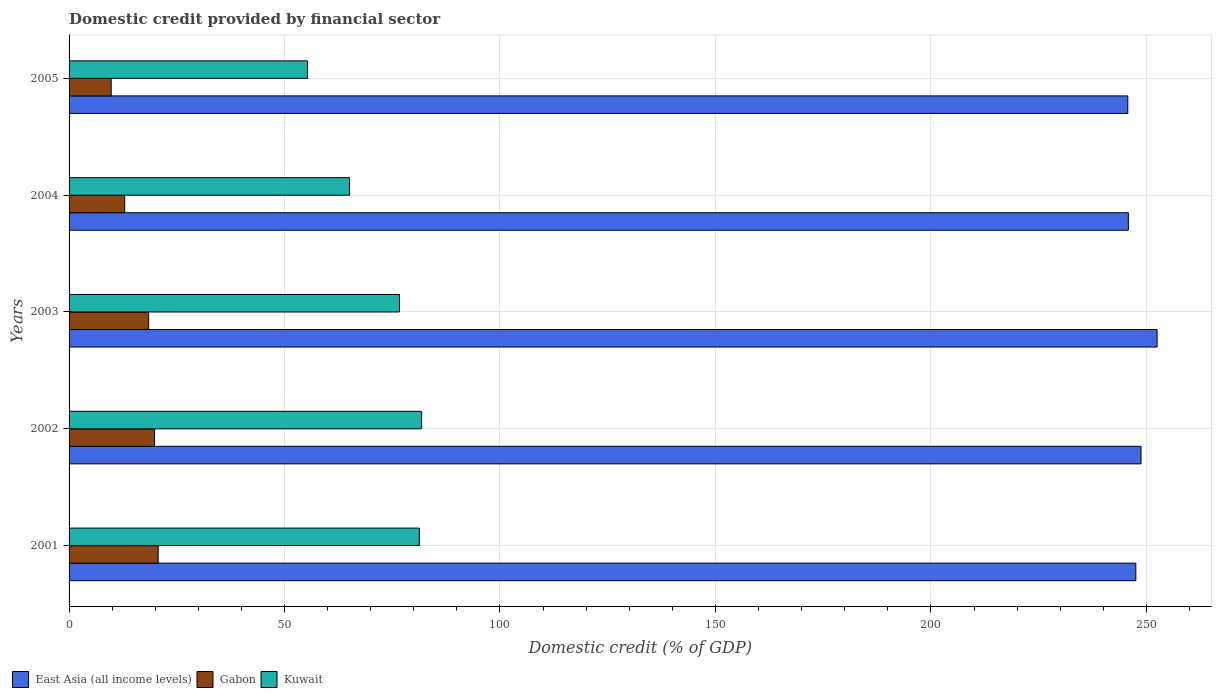How many groups of bars are there?
Provide a succinct answer. 5. Are the number of bars per tick equal to the number of legend labels?
Provide a succinct answer. Yes. Are the number of bars on each tick of the Y-axis equal?
Give a very brief answer. Yes. How many bars are there on the 4th tick from the top?
Offer a terse response. 3. What is the label of the 5th group of bars from the top?
Make the answer very short. 2001. In how many cases, is the number of bars for a given year not equal to the number of legend labels?
Provide a short and direct response. 0. What is the domestic credit in East Asia (all income levels) in 2004?
Provide a short and direct response. 245.82. Across all years, what is the maximum domestic credit in East Asia (all income levels)?
Provide a short and direct response. 252.49. Across all years, what is the minimum domestic credit in Gabon?
Your answer should be compact. 9.77. In which year was the domestic credit in Gabon maximum?
Give a very brief answer. 2001. What is the total domestic credit in East Asia (all income levels) in the graph?
Your answer should be very brief. 1240.33. What is the difference between the domestic credit in East Asia (all income levels) in 2001 and that in 2003?
Give a very brief answer. -4.93. What is the difference between the domestic credit in Kuwait in 2005 and the domestic credit in East Asia (all income levels) in 2002?
Give a very brief answer. -193.44. What is the average domestic credit in Gabon per year?
Make the answer very short. 16.33. In the year 2005, what is the difference between the domestic credit in Gabon and domestic credit in Kuwait?
Ensure brevity in your answer.  -45.55. In how many years, is the domestic credit in Gabon greater than 130 %?
Make the answer very short. 0. What is the ratio of the domestic credit in Gabon in 2002 to that in 2005?
Your answer should be compact. 2.03. Is the domestic credit in East Asia (all income levels) in 2003 less than that in 2004?
Keep it short and to the point. No. What is the difference between the highest and the second highest domestic credit in Gabon?
Provide a short and direct response. 0.86. What is the difference between the highest and the lowest domestic credit in Kuwait?
Provide a short and direct response. 26.49. In how many years, is the domestic credit in Kuwait greater than the average domestic credit in Kuwait taken over all years?
Your response must be concise. 3. What does the 1st bar from the top in 2003 represents?
Offer a terse response. Kuwait. What does the 2nd bar from the bottom in 2004 represents?
Provide a short and direct response. Gabon. Are all the bars in the graph horizontal?
Your answer should be very brief. Yes. How many years are there in the graph?
Your response must be concise. 5. What is the difference between two consecutive major ticks on the X-axis?
Make the answer very short. 50. Are the values on the major ticks of X-axis written in scientific E-notation?
Your answer should be very brief. No. Does the graph contain grids?
Ensure brevity in your answer.  Yes. Where does the legend appear in the graph?
Keep it short and to the point. Bottom left. How are the legend labels stacked?
Your response must be concise. Horizontal. What is the title of the graph?
Your answer should be compact. Domestic credit provided by financial sector. Does "Belarus" appear as one of the legend labels in the graph?
Keep it short and to the point. No. What is the label or title of the X-axis?
Your response must be concise. Domestic credit (% of GDP). What is the Domestic credit (% of GDP) of East Asia (all income levels) in 2001?
Keep it short and to the point. 247.56. What is the Domestic credit (% of GDP) in Gabon in 2001?
Your answer should be very brief. 20.68. What is the Domestic credit (% of GDP) of Kuwait in 2001?
Provide a short and direct response. 81.27. What is the Domestic credit (% of GDP) of East Asia (all income levels) in 2002?
Your response must be concise. 248.76. What is the Domestic credit (% of GDP) of Gabon in 2002?
Keep it short and to the point. 19.82. What is the Domestic credit (% of GDP) of Kuwait in 2002?
Provide a short and direct response. 81.81. What is the Domestic credit (% of GDP) of East Asia (all income levels) in 2003?
Give a very brief answer. 252.49. What is the Domestic credit (% of GDP) of Gabon in 2003?
Make the answer very short. 18.47. What is the Domestic credit (% of GDP) in Kuwait in 2003?
Ensure brevity in your answer.  76.68. What is the Domestic credit (% of GDP) of East Asia (all income levels) in 2004?
Give a very brief answer. 245.82. What is the Domestic credit (% of GDP) of Gabon in 2004?
Provide a succinct answer. 12.91. What is the Domestic credit (% of GDP) in Kuwait in 2004?
Make the answer very short. 65.09. What is the Domestic credit (% of GDP) of East Asia (all income levels) in 2005?
Make the answer very short. 245.69. What is the Domestic credit (% of GDP) in Gabon in 2005?
Provide a succinct answer. 9.77. What is the Domestic credit (% of GDP) in Kuwait in 2005?
Your answer should be compact. 55.32. Across all years, what is the maximum Domestic credit (% of GDP) in East Asia (all income levels)?
Your answer should be compact. 252.49. Across all years, what is the maximum Domestic credit (% of GDP) of Gabon?
Offer a very short reply. 20.68. Across all years, what is the maximum Domestic credit (% of GDP) of Kuwait?
Ensure brevity in your answer.  81.81. Across all years, what is the minimum Domestic credit (% of GDP) in East Asia (all income levels)?
Give a very brief answer. 245.69. Across all years, what is the minimum Domestic credit (% of GDP) of Gabon?
Your answer should be very brief. 9.77. Across all years, what is the minimum Domestic credit (% of GDP) of Kuwait?
Your answer should be compact. 55.32. What is the total Domestic credit (% of GDP) of East Asia (all income levels) in the graph?
Keep it short and to the point. 1240.33. What is the total Domestic credit (% of GDP) in Gabon in the graph?
Your answer should be compact. 81.65. What is the total Domestic credit (% of GDP) of Kuwait in the graph?
Your answer should be compact. 360.18. What is the difference between the Domestic credit (% of GDP) in East Asia (all income levels) in 2001 and that in 2002?
Offer a terse response. -1.21. What is the difference between the Domestic credit (% of GDP) of Gabon in 2001 and that in 2002?
Your response must be concise. 0.86. What is the difference between the Domestic credit (% of GDP) in Kuwait in 2001 and that in 2002?
Provide a short and direct response. -0.54. What is the difference between the Domestic credit (% of GDP) of East Asia (all income levels) in 2001 and that in 2003?
Your response must be concise. -4.93. What is the difference between the Domestic credit (% of GDP) in Gabon in 2001 and that in 2003?
Your response must be concise. 2.22. What is the difference between the Domestic credit (% of GDP) in Kuwait in 2001 and that in 2003?
Make the answer very short. 4.6. What is the difference between the Domestic credit (% of GDP) of East Asia (all income levels) in 2001 and that in 2004?
Make the answer very short. 1.74. What is the difference between the Domestic credit (% of GDP) of Gabon in 2001 and that in 2004?
Your answer should be compact. 7.77. What is the difference between the Domestic credit (% of GDP) in Kuwait in 2001 and that in 2004?
Make the answer very short. 16.18. What is the difference between the Domestic credit (% of GDP) in East Asia (all income levels) in 2001 and that in 2005?
Offer a very short reply. 1.87. What is the difference between the Domestic credit (% of GDP) in Gabon in 2001 and that in 2005?
Ensure brevity in your answer.  10.91. What is the difference between the Domestic credit (% of GDP) in Kuwait in 2001 and that in 2005?
Provide a short and direct response. 25.95. What is the difference between the Domestic credit (% of GDP) in East Asia (all income levels) in 2002 and that in 2003?
Provide a short and direct response. -3.72. What is the difference between the Domestic credit (% of GDP) of Gabon in 2002 and that in 2003?
Your response must be concise. 1.36. What is the difference between the Domestic credit (% of GDP) of Kuwait in 2002 and that in 2003?
Your answer should be very brief. 5.13. What is the difference between the Domestic credit (% of GDP) of East Asia (all income levels) in 2002 and that in 2004?
Keep it short and to the point. 2.94. What is the difference between the Domestic credit (% of GDP) of Gabon in 2002 and that in 2004?
Provide a succinct answer. 6.92. What is the difference between the Domestic credit (% of GDP) in Kuwait in 2002 and that in 2004?
Your answer should be compact. 16.72. What is the difference between the Domestic credit (% of GDP) in East Asia (all income levels) in 2002 and that in 2005?
Ensure brevity in your answer.  3.07. What is the difference between the Domestic credit (% of GDP) in Gabon in 2002 and that in 2005?
Offer a very short reply. 10.05. What is the difference between the Domestic credit (% of GDP) of Kuwait in 2002 and that in 2005?
Ensure brevity in your answer.  26.49. What is the difference between the Domestic credit (% of GDP) in East Asia (all income levels) in 2003 and that in 2004?
Make the answer very short. 6.67. What is the difference between the Domestic credit (% of GDP) in Gabon in 2003 and that in 2004?
Offer a very short reply. 5.56. What is the difference between the Domestic credit (% of GDP) of Kuwait in 2003 and that in 2004?
Keep it short and to the point. 11.59. What is the difference between the Domestic credit (% of GDP) in East Asia (all income levels) in 2003 and that in 2005?
Provide a short and direct response. 6.8. What is the difference between the Domestic credit (% of GDP) of Gabon in 2003 and that in 2005?
Ensure brevity in your answer.  8.69. What is the difference between the Domestic credit (% of GDP) in Kuwait in 2003 and that in 2005?
Give a very brief answer. 21.36. What is the difference between the Domestic credit (% of GDP) in East Asia (all income levels) in 2004 and that in 2005?
Provide a succinct answer. 0.13. What is the difference between the Domestic credit (% of GDP) of Gabon in 2004 and that in 2005?
Provide a succinct answer. 3.14. What is the difference between the Domestic credit (% of GDP) in Kuwait in 2004 and that in 2005?
Offer a terse response. 9.77. What is the difference between the Domestic credit (% of GDP) of East Asia (all income levels) in 2001 and the Domestic credit (% of GDP) of Gabon in 2002?
Your answer should be compact. 227.74. What is the difference between the Domestic credit (% of GDP) of East Asia (all income levels) in 2001 and the Domestic credit (% of GDP) of Kuwait in 2002?
Your answer should be very brief. 165.75. What is the difference between the Domestic credit (% of GDP) of Gabon in 2001 and the Domestic credit (% of GDP) of Kuwait in 2002?
Give a very brief answer. -61.13. What is the difference between the Domestic credit (% of GDP) in East Asia (all income levels) in 2001 and the Domestic credit (% of GDP) in Gabon in 2003?
Ensure brevity in your answer.  229.09. What is the difference between the Domestic credit (% of GDP) of East Asia (all income levels) in 2001 and the Domestic credit (% of GDP) of Kuwait in 2003?
Provide a succinct answer. 170.88. What is the difference between the Domestic credit (% of GDP) in Gabon in 2001 and the Domestic credit (% of GDP) in Kuwait in 2003?
Your answer should be very brief. -56. What is the difference between the Domestic credit (% of GDP) in East Asia (all income levels) in 2001 and the Domestic credit (% of GDP) in Gabon in 2004?
Provide a succinct answer. 234.65. What is the difference between the Domestic credit (% of GDP) of East Asia (all income levels) in 2001 and the Domestic credit (% of GDP) of Kuwait in 2004?
Offer a terse response. 182.47. What is the difference between the Domestic credit (% of GDP) in Gabon in 2001 and the Domestic credit (% of GDP) in Kuwait in 2004?
Give a very brief answer. -44.41. What is the difference between the Domestic credit (% of GDP) of East Asia (all income levels) in 2001 and the Domestic credit (% of GDP) of Gabon in 2005?
Offer a terse response. 237.79. What is the difference between the Domestic credit (% of GDP) in East Asia (all income levels) in 2001 and the Domestic credit (% of GDP) in Kuwait in 2005?
Give a very brief answer. 192.24. What is the difference between the Domestic credit (% of GDP) of Gabon in 2001 and the Domestic credit (% of GDP) of Kuwait in 2005?
Ensure brevity in your answer.  -34.64. What is the difference between the Domestic credit (% of GDP) of East Asia (all income levels) in 2002 and the Domestic credit (% of GDP) of Gabon in 2003?
Ensure brevity in your answer.  230.3. What is the difference between the Domestic credit (% of GDP) of East Asia (all income levels) in 2002 and the Domestic credit (% of GDP) of Kuwait in 2003?
Offer a very short reply. 172.09. What is the difference between the Domestic credit (% of GDP) of Gabon in 2002 and the Domestic credit (% of GDP) of Kuwait in 2003?
Make the answer very short. -56.85. What is the difference between the Domestic credit (% of GDP) in East Asia (all income levels) in 2002 and the Domestic credit (% of GDP) in Gabon in 2004?
Ensure brevity in your answer.  235.86. What is the difference between the Domestic credit (% of GDP) of East Asia (all income levels) in 2002 and the Domestic credit (% of GDP) of Kuwait in 2004?
Your answer should be compact. 183.67. What is the difference between the Domestic credit (% of GDP) of Gabon in 2002 and the Domestic credit (% of GDP) of Kuwait in 2004?
Keep it short and to the point. -45.27. What is the difference between the Domestic credit (% of GDP) in East Asia (all income levels) in 2002 and the Domestic credit (% of GDP) in Gabon in 2005?
Offer a terse response. 238.99. What is the difference between the Domestic credit (% of GDP) in East Asia (all income levels) in 2002 and the Domestic credit (% of GDP) in Kuwait in 2005?
Your answer should be very brief. 193.44. What is the difference between the Domestic credit (% of GDP) in Gabon in 2002 and the Domestic credit (% of GDP) in Kuwait in 2005?
Make the answer very short. -35.5. What is the difference between the Domestic credit (% of GDP) of East Asia (all income levels) in 2003 and the Domestic credit (% of GDP) of Gabon in 2004?
Make the answer very short. 239.58. What is the difference between the Domestic credit (% of GDP) of East Asia (all income levels) in 2003 and the Domestic credit (% of GDP) of Kuwait in 2004?
Give a very brief answer. 187.4. What is the difference between the Domestic credit (% of GDP) in Gabon in 2003 and the Domestic credit (% of GDP) in Kuwait in 2004?
Provide a succinct answer. -46.63. What is the difference between the Domestic credit (% of GDP) of East Asia (all income levels) in 2003 and the Domestic credit (% of GDP) of Gabon in 2005?
Make the answer very short. 242.72. What is the difference between the Domestic credit (% of GDP) in East Asia (all income levels) in 2003 and the Domestic credit (% of GDP) in Kuwait in 2005?
Your answer should be very brief. 197.17. What is the difference between the Domestic credit (% of GDP) in Gabon in 2003 and the Domestic credit (% of GDP) in Kuwait in 2005?
Give a very brief answer. -36.86. What is the difference between the Domestic credit (% of GDP) of East Asia (all income levels) in 2004 and the Domestic credit (% of GDP) of Gabon in 2005?
Provide a short and direct response. 236.05. What is the difference between the Domestic credit (% of GDP) of East Asia (all income levels) in 2004 and the Domestic credit (% of GDP) of Kuwait in 2005?
Your response must be concise. 190.5. What is the difference between the Domestic credit (% of GDP) of Gabon in 2004 and the Domestic credit (% of GDP) of Kuwait in 2005?
Your response must be concise. -42.41. What is the average Domestic credit (% of GDP) in East Asia (all income levels) per year?
Ensure brevity in your answer.  248.07. What is the average Domestic credit (% of GDP) of Gabon per year?
Ensure brevity in your answer.  16.33. What is the average Domestic credit (% of GDP) in Kuwait per year?
Your answer should be compact. 72.03. In the year 2001, what is the difference between the Domestic credit (% of GDP) of East Asia (all income levels) and Domestic credit (% of GDP) of Gabon?
Offer a terse response. 226.88. In the year 2001, what is the difference between the Domestic credit (% of GDP) in East Asia (all income levels) and Domestic credit (% of GDP) in Kuwait?
Your answer should be very brief. 166.28. In the year 2001, what is the difference between the Domestic credit (% of GDP) of Gabon and Domestic credit (% of GDP) of Kuwait?
Keep it short and to the point. -60.59. In the year 2002, what is the difference between the Domestic credit (% of GDP) in East Asia (all income levels) and Domestic credit (% of GDP) in Gabon?
Keep it short and to the point. 228.94. In the year 2002, what is the difference between the Domestic credit (% of GDP) of East Asia (all income levels) and Domestic credit (% of GDP) of Kuwait?
Provide a succinct answer. 166.95. In the year 2002, what is the difference between the Domestic credit (% of GDP) of Gabon and Domestic credit (% of GDP) of Kuwait?
Provide a short and direct response. -61.99. In the year 2003, what is the difference between the Domestic credit (% of GDP) in East Asia (all income levels) and Domestic credit (% of GDP) in Gabon?
Your answer should be very brief. 234.02. In the year 2003, what is the difference between the Domestic credit (% of GDP) of East Asia (all income levels) and Domestic credit (% of GDP) of Kuwait?
Offer a very short reply. 175.81. In the year 2003, what is the difference between the Domestic credit (% of GDP) of Gabon and Domestic credit (% of GDP) of Kuwait?
Give a very brief answer. -58.21. In the year 2004, what is the difference between the Domestic credit (% of GDP) of East Asia (all income levels) and Domestic credit (% of GDP) of Gabon?
Give a very brief answer. 232.92. In the year 2004, what is the difference between the Domestic credit (% of GDP) of East Asia (all income levels) and Domestic credit (% of GDP) of Kuwait?
Your answer should be very brief. 180.73. In the year 2004, what is the difference between the Domestic credit (% of GDP) of Gabon and Domestic credit (% of GDP) of Kuwait?
Make the answer very short. -52.18. In the year 2005, what is the difference between the Domestic credit (% of GDP) of East Asia (all income levels) and Domestic credit (% of GDP) of Gabon?
Offer a terse response. 235.92. In the year 2005, what is the difference between the Domestic credit (% of GDP) in East Asia (all income levels) and Domestic credit (% of GDP) in Kuwait?
Offer a very short reply. 190.37. In the year 2005, what is the difference between the Domestic credit (% of GDP) of Gabon and Domestic credit (% of GDP) of Kuwait?
Make the answer very short. -45.55. What is the ratio of the Domestic credit (% of GDP) in East Asia (all income levels) in 2001 to that in 2002?
Offer a very short reply. 1. What is the ratio of the Domestic credit (% of GDP) of Gabon in 2001 to that in 2002?
Offer a very short reply. 1.04. What is the ratio of the Domestic credit (% of GDP) of Kuwait in 2001 to that in 2002?
Offer a very short reply. 0.99. What is the ratio of the Domestic credit (% of GDP) of East Asia (all income levels) in 2001 to that in 2003?
Provide a succinct answer. 0.98. What is the ratio of the Domestic credit (% of GDP) of Gabon in 2001 to that in 2003?
Offer a very short reply. 1.12. What is the ratio of the Domestic credit (% of GDP) in Kuwait in 2001 to that in 2003?
Provide a short and direct response. 1.06. What is the ratio of the Domestic credit (% of GDP) of East Asia (all income levels) in 2001 to that in 2004?
Ensure brevity in your answer.  1.01. What is the ratio of the Domestic credit (% of GDP) of Gabon in 2001 to that in 2004?
Offer a terse response. 1.6. What is the ratio of the Domestic credit (% of GDP) of Kuwait in 2001 to that in 2004?
Provide a short and direct response. 1.25. What is the ratio of the Domestic credit (% of GDP) in East Asia (all income levels) in 2001 to that in 2005?
Provide a short and direct response. 1.01. What is the ratio of the Domestic credit (% of GDP) in Gabon in 2001 to that in 2005?
Provide a short and direct response. 2.12. What is the ratio of the Domestic credit (% of GDP) in Kuwait in 2001 to that in 2005?
Ensure brevity in your answer.  1.47. What is the ratio of the Domestic credit (% of GDP) in East Asia (all income levels) in 2002 to that in 2003?
Your response must be concise. 0.99. What is the ratio of the Domestic credit (% of GDP) of Gabon in 2002 to that in 2003?
Your answer should be very brief. 1.07. What is the ratio of the Domestic credit (% of GDP) of Kuwait in 2002 to that in 2003?
Give a very brief answer. 1.07. What is the ratio of the Domestic credit (% of GDP) of Gabon in 2002 to that in 2004?
Ensure brevity in your answer.  1.54. What is the ratio of the Domestic credit (% of GDP) in Kuwait in 2002 to that in 2004?
Your answer should be compact. 1.26. What is the ratio of the Domestic credit (% of GDP) in East Asia (all income levels) in 2002 to that in 2005?
Your answer should be compact. 1.01. What is the ratio of the Domestic credit (% of GDP) of Gabon in 2002 to that in 2005?
Offer a very short reply. 2.03. What is the ratio of the Domestic credit (% of GDP) in Kuwait in 2002 to that in 2005?
Make the answer very short. 1.48. What is the ratio of the Domestic credit (% of GDP) of East Asia (all income levels) in 2003 to that in 2004?
Offer a terse response. 1.03. What is the ratio of the Domestic credit (% of GDP) of Gabon in 2003 to that in 2004?
Offer a very short reply. 1.43. What is the ratio of the Domestic credit (% of GDP) of Kuwait in 2003 to that in 2004?
Give a very brief answer. 1.18. What is the ratio of the Domestic credit (% of GDP) of East Asia (all income levels) in 2003 to that in 2005?
Give a very brief answer. 1.03. What is the ratio of the Domestic credit (% of GDP) in Gabon in 2003 to that in 2005?
Your answer should be compact. 1.89. What is the ratio of the Domestic credit (% of GDP) of Kuwait in 2003 to that in 2005?
Provide a succinct answer. 1.39. What is the ratio of the Domestic credit (% of GDP) in East Asia (all income levels) in 2004 to that in 2005?
Ensure brevity in your answer.  1. What is the ratio of the Domestic credit (% of GDP) in Gabon in 2004 to that in 2005?
Keep it short and to the point. 1.32. What is the ratio of the Domestic credit (% of GDP) in Kuwait in 2004 to that in 2005?
Make the answer very short. 1.18. What is the difference between the highest and the second highest Domestic credit (% of GDP) of East Asia (all income levels)?
Your answer should be very brief. 3.72. What is the difference between the highest and the second highest Domestic credit (% of GDP) of Gabon?
Offer a very short reply. 0.86. What is the difference between the highest and the second highest Domestic credit (% of GDP) of Kuwait?
Keep it short and to the point. 0.54. What is the difference between the highest and the lowest Domestic credit (% of GDP) of East Asia (all income levels)?
Offer a very short reply. 6.8. What is the difference between the highest and the lowest Domestic credit (% of GDP) in Gabon?
Give a very brief answer. 10.91. What is the difference between the highest and the lowest Domestic credit (% of GDP) in Kuwait?
Offer a terse response. 26.49. 